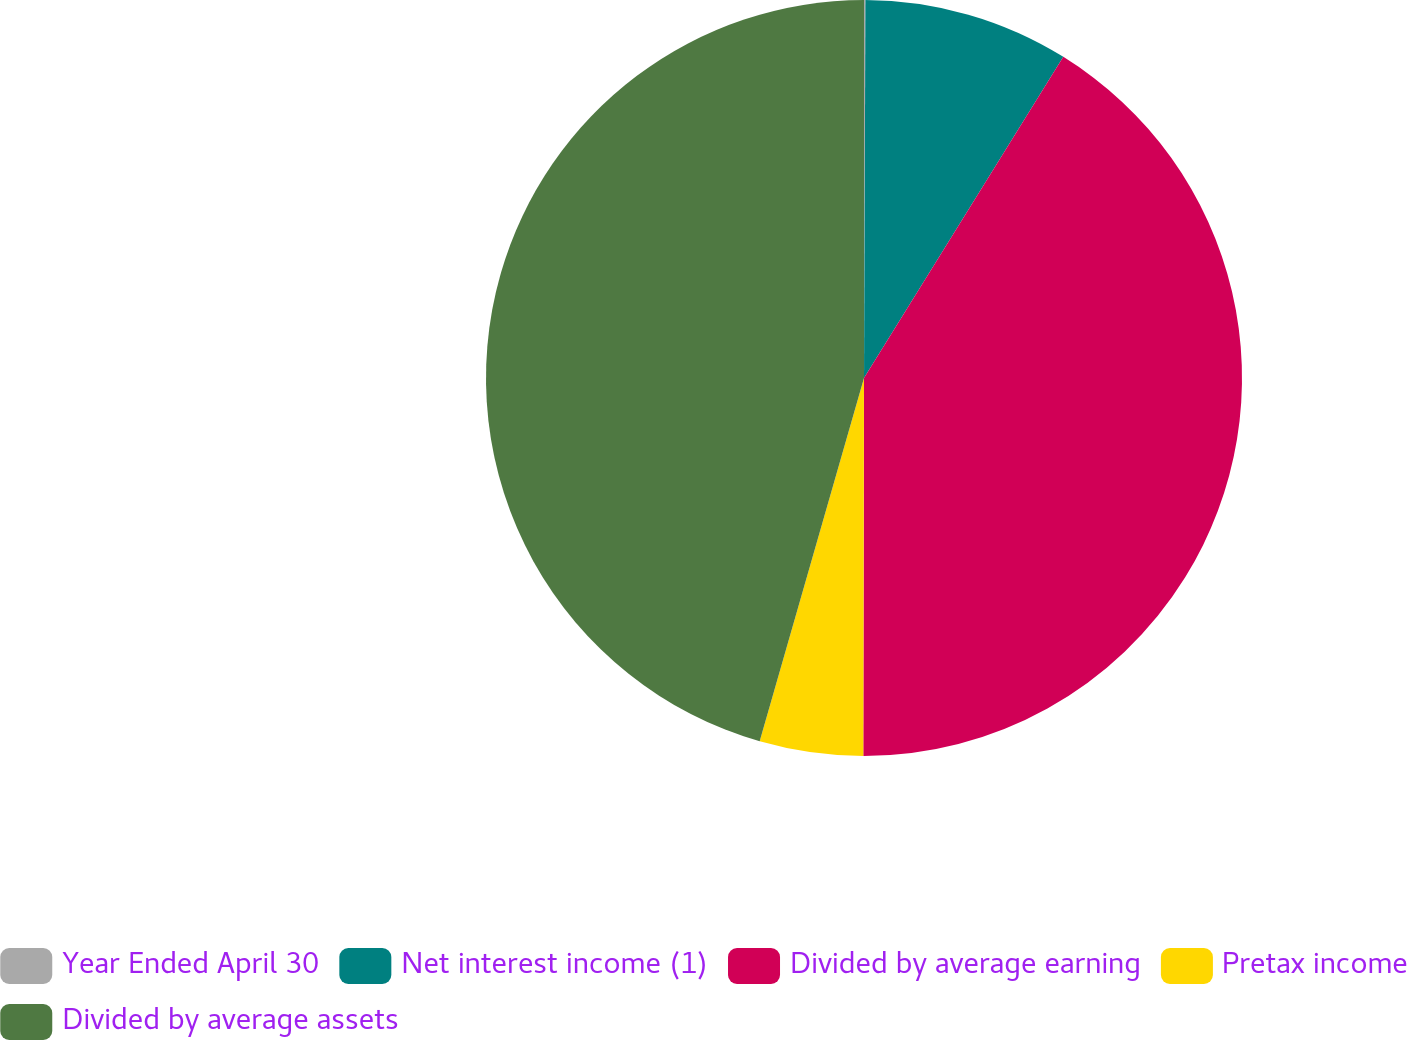Convert chart to OTSL. <chart><loc_0><loc_0><loc_500><loc_500><pie_chart><fcel>Year Ended April 30<fcel>Net interest income (1)<fcel>Divided by average earning<fcel>Pretax income<fcel>Divided by average assets<nl><fcel>0.06%<fcel>8.78%<fcel>41.19%<fcel>4.42%<fcel>45.55%<nl></chart> 